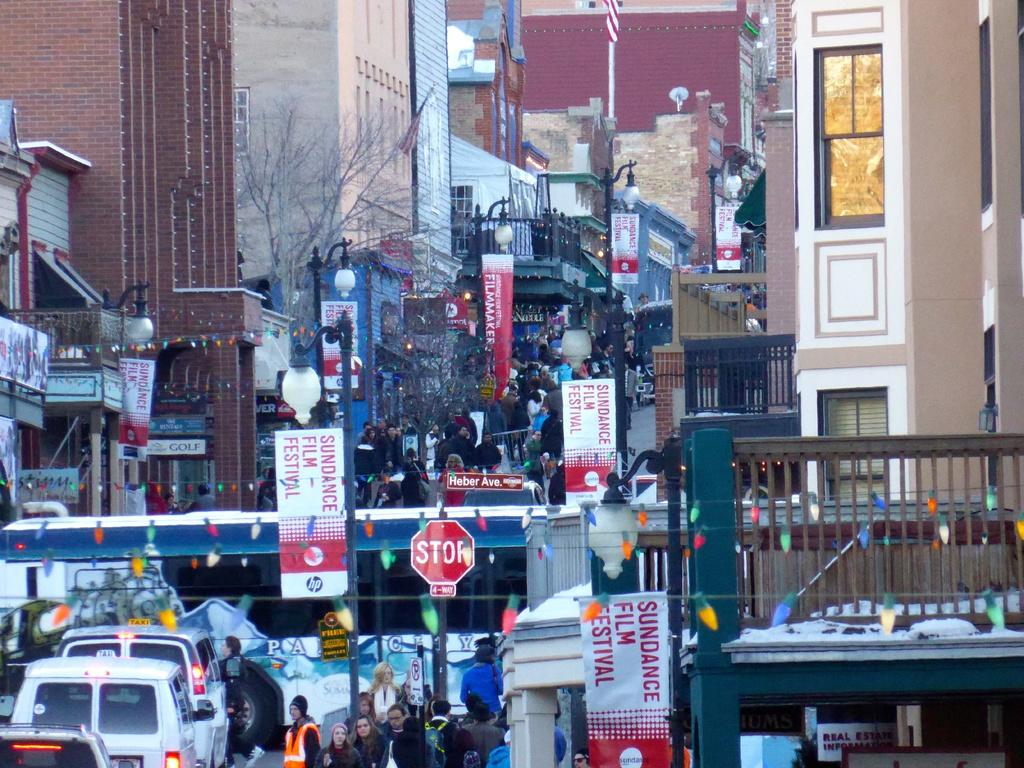What type of structures can be seen in the image? There are buildings in the image. What else is present in the image besides buildings? There are vehicles, persons, advertisements, poles, name boards, fencing, and trees in the image. Can you describe the vehicles in the image? The vehicles in the image are not specified, but they are present. What type of information might be conveyed by the sign board in the image? The sign board in the image might convey information such as directions, warnings, or advertisements. Can you tell me how much your aunt weighs on the scale in the image? There is no scale or your aunt present in the image. What type of airplane can be seen flying over the buildings in the image? There is no airplane visible in the image; it only features buildings, vehicles, persons, advertisements, poles, name boards, fencing, sign boards, and trees. 